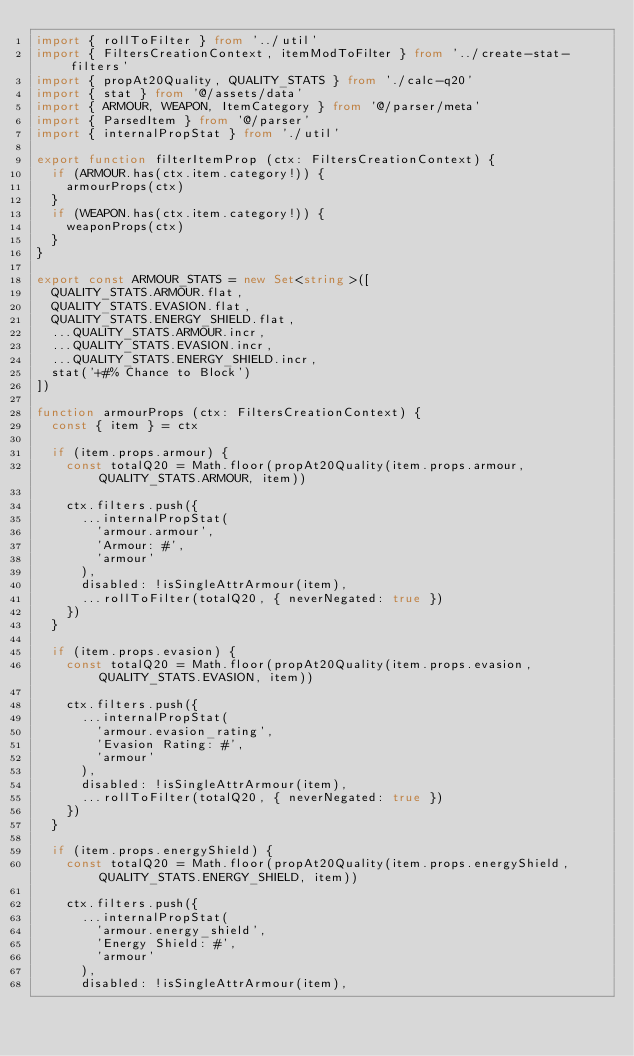<code> <loc_0><loc_0><loc_500><loc_500><_TypeScript_>import { rollToFilter } from '../util'
import { FiltersCreationContext, itemModToFilter } from '../create-stat-filters'
import { propAt20Quality, QUALITY_STATS } from './calc-q20'
import { stat } from '@/assets/data'
import { ARMOUR, WEAPON, ItemCategory } from '@/parser/meta'
import { ParsedItem } from '@/parser'
import { internalPropStat } from './util'

export function filterItemProp (ctx: FiltersCreationContext) {
  if (ARMOUR.has(ctx.item.category!)) {
    armourProps(ctx)
  }
  if (WEAPON.has(ctx.item.category!)) {
    weaponProps(ctx)
  }
}

export const ARMOUR_STATS = new Set<string>([
  QUALITY_STATS.ARMOUR.flat,
  QUALITY_STATS.EVASION.flat,
  QUALITY_STATS.ENERGY_SHIELD.flat,
  ...QUALITY_STATS.ARMOUR.incr,
  ...QUALITY_STATS.EVASION.incr,
  ...QUALITY_STATS.ENERGY_SHIELD.incr,
  stat('+#% Chance to Block')
])

function armourProps (ctx: FiltersCreationContext) {
  const { item } = ctx

  if (item.props.armour) {
    const totalQ20 = Math.floor(propAt20Quality(item.props.armour, QUALITY_STATS.ARMOUR, item))

    ctx.filters.push({
      ...internalPropStat(
        'armour.armour',
        'Armour: #',
        'armour'
      ),
      disabled: !isSingleAttrArmour(item),
      ...rollToFilter(totalQ20, { neverNegated: true })
    })
  }

  if (item.props.evasion) {
    const totalQ20 = Math.floor(propAt20Quality(item.props.evasion, QUALITY_STATS.EVASION, item))

    ctx.filters.push({
      ...internalPropStat(
        'armour.evasion_rating',
        'Evasion Rating: #',
        'armour'
      ),
      disabled: !isSingleAttrArmour(item),
      ...rollToFilter(totalQ20, { neverNegated: true })
    })
  }

  if (item.props.energyShield) {
    const totalQ20 = Math.floor(propAt20Quality(item.props.energyShield, QUALITY_STATS.ENERGY_SHIELD, item))

    ctx.filters.push({
      ...internalPropStat(
        'armour.energy_shield',
        'Energy Shield: #',
        'armour'
      ),
      disabled: !isSingleAttrArmour(item),</code> 